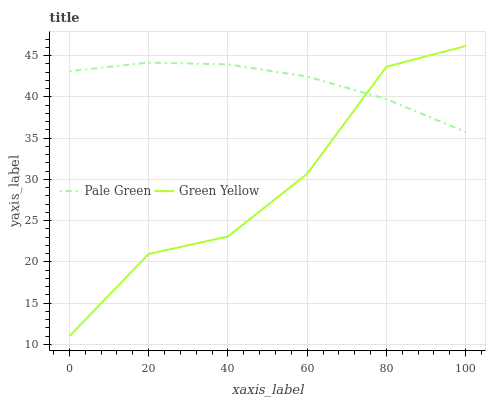Does Green Yellow have the minimum area under the curve?
Answer yes or no. Yes. Does Pale Green have the maximum area under the curve?
Answer yes or no. Yes. Does Pale Green have the minimum area under the curve?
Answer yes or no. No. Is Pale Green the smoothest?
Answer yes or no. Yes. Is Green Yellow the roughest?
Answer yes or no. Yes. Is Pale Green the roughest?
Answer yes or no. No. Does Green Yellow have the lowest value?
Answer yes or no. Yes. Does Pale Green have the lowest value?
Answer yes or no. No. Does Green Yellow have the highest value?
Answer yes or no. Yes. Does Pale Green have the highest value?
Answer yes or no. No. Does Green Yellow intersect Pale Green?
Answer yes or no. Yes. Is Green Yellow less than Pale Green?
Answer yes or no. No. Is Green Yellow greater than Pale Green?
Answer yes or no. No. 